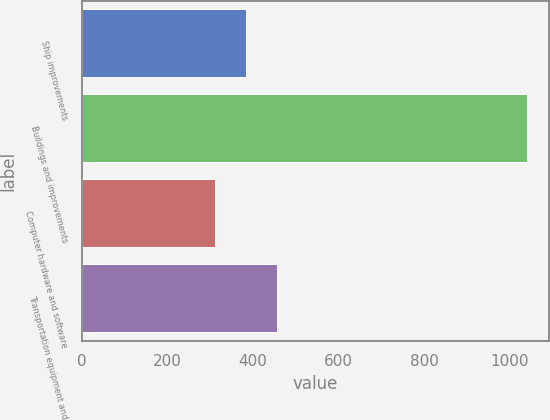Convert chart. <chart><loc_0><loc_0><loc_500><loc_500><bar_chart><fcel>Ship improvements<fcel>Buildings and improvements<fcel>Computer hardware and software<fcel>Transportation equipment and<nl><fcel>383<fcel>1040<fcel>310<fcel>456<nl></chart> 